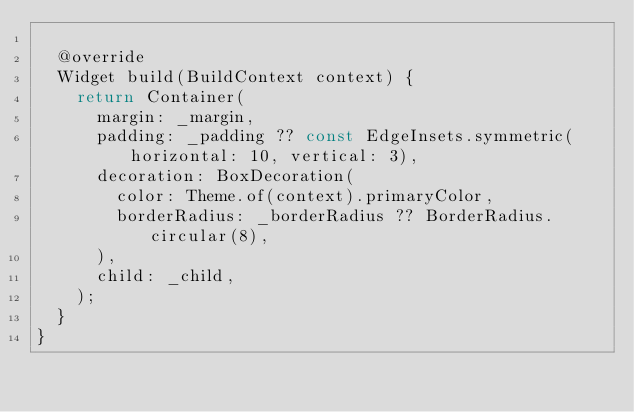Convert code to text. <code><loc_0><loc_0><loc_500><loc_500><_Dart_>
  @override
  Widget build(BuildContext context) {
    return Container(
      margin: _margin,
      padding: _padding ?? const EdgeInsets.symmetric(horizontal: 10, vertical: 3),
      decoration: BoxDecoration(
        color: Theme.of(context).primaryColor,
        borderRadius: _borderRadius ?? BorderRadius.circular(8),
      ),
      child: _child,
    );
  }
}
</code> 